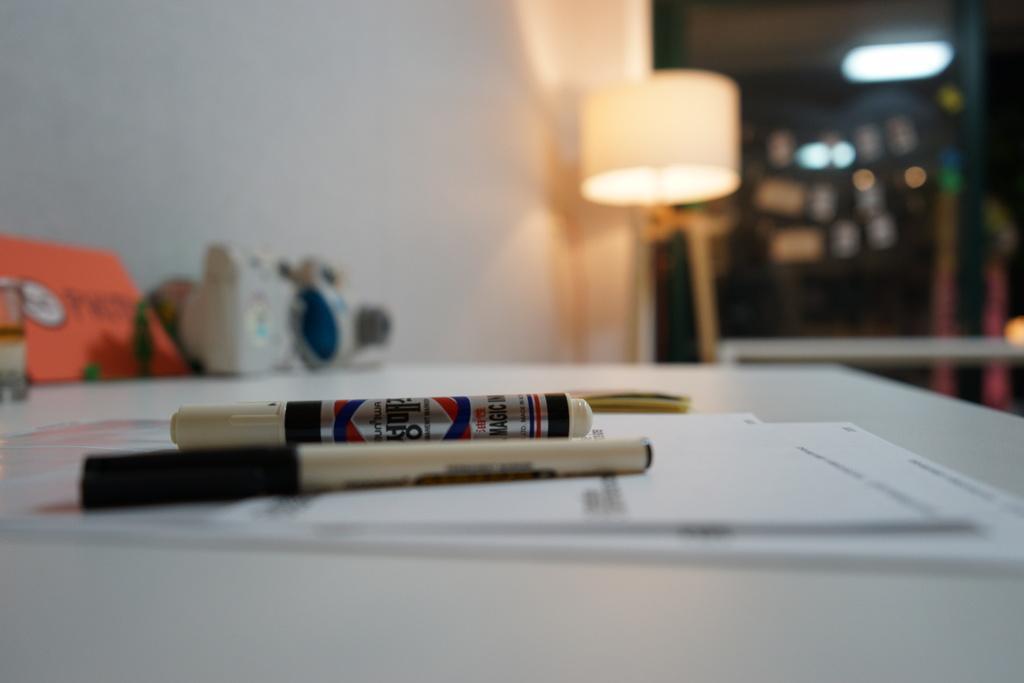How would you summarize this image in a sentence or two? In the image there is a table with markers,papers and books on it and behind there is a lamp beside the wall followed by a glass wall. 